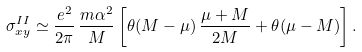Convert formula to latex. <formula><loc_0><loc_0><loc_500><loc_500>\sigma ^ { I I } _ { x y } \simeq \frac { e ^ { 2 } } { 2 \pi } \, \frac { m \alpha ^ { 2 } } { M } \left [ \theta ( M - \mu ) \, \frac { \mu + M } { 2 M } + \theta ( \mu - M ) \right ] .</formula> 